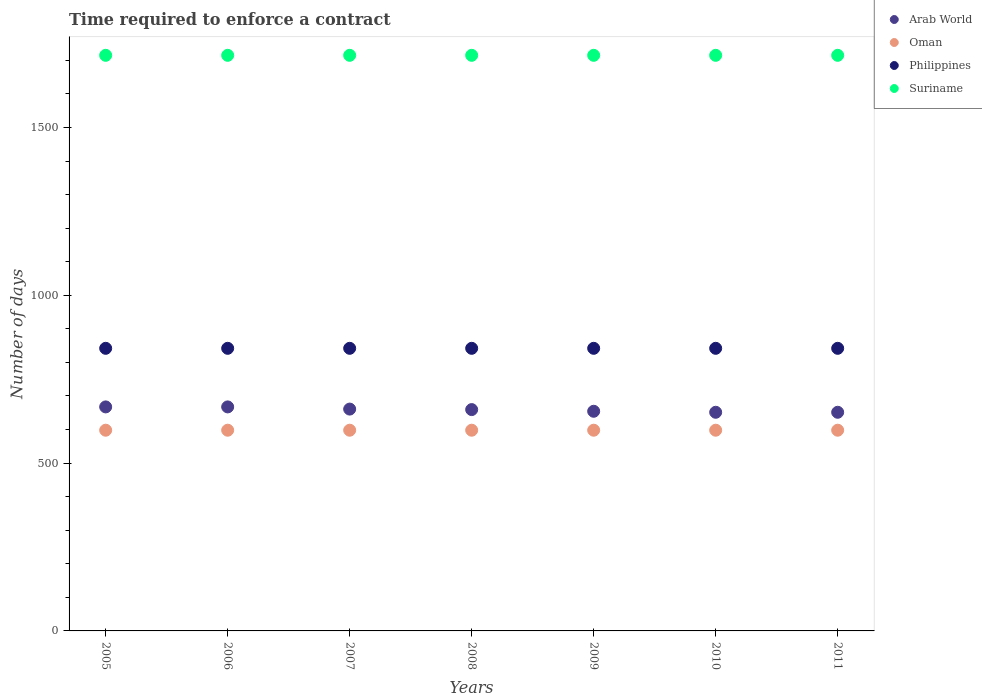What is the number of days required to enforce a contract in Oman in 2007?
Ensure brevity in your answer.  598. Across all years, what is the maximum number of days required to enforce a contract in Oman?
Your answer should be very brief. 598. Across all years, what is the minimum number of days required to enforce a contract in Arab World?
Give a very brief answer. 651.45. In which year was the number of days required to enforce a contract in Suriname maximum?
Ensure brevity in your answer.  2005. What is the total number of days required to enforce a contract in Suriname in the graph?
Offer a terse response. 1.20e+04. What is the difference between the number of days required to enforce a contract in Arab World in 2006 and that in 2008?
Give a very brief answer. 7.99. What is the difference between the number of days required to enforce a contract in Suriname in 2006 and the number of days required to enforce a contract in Philippines in 2010?
Your response must be concise. 873. What is the average number of days required to enforce a contract in Oman per year?
Your answer should be compact. 598. In the year 2006, what is the difference between the number of days required to enforce a contract in Arab World and number of days required to enforce a contract in Oman?
Give a very brief answer. 69.44. In how many years, is the number of days required to enforce a contract in Philippines greater than 1200 days?
Your response must be concise. 0. What is the ratio of the number of days required to enforce a contract in Suriname in 2008 to that in 2009?
Ensure brevity in your answer.  1. Is the difference between the number of days required to enforce a contract in Arab World in 2005 and 2008 greater than the difference between the number of days required to enforce a contract in Oman in 2005 and 2008?
Provide a short and direct response. Yes. What is the difference between the highest and the lowest number of days required to enforce a contract in Suriname?
Provide a short and direct response. 0. In how many years, is the number of days required to enforce a contract in Philippines greater than the average number of days required to enforce a contract in Philippines taken over all years?
Offer a very short reply. 0. Is it the case that in every year, the sum of the number of days required to enforce a contract in Arab World and number of days required to enforce a contract in Oman  is greater than the number of days required to enforce a contract in Suriname?
Give a very brief answer. No. Is the number of days required to enforce a contract in Oman strictly greater than the number of days required to enforce a contract in Suriname over the years?
Give a very brief answer. No. How many years are there in the graph?
Make the answer very short. 7. What is the difference between two consecutive major ticks on the Y-axis?
Offer a terse response. 500. Where does the legend appear in the graph?
Ensure brevity in your answer.  Top right. How are the legend labels stacked?
Your answer should be compact. Vertical. What is the title of the graph?
Provide a short and direct response. Time required to enforce a contract. Does "St. Martin (French part)" appear as one of the legend labels in the graph?
Provide a succinct answer. No. What is the label or title of the Y-axis?
Your answer should be very brief. Number of days. What is the Number of days of Arab World in 2005?
Your answer should be very brief. 667.44. What is the Number of days in Oman in 2005?
Provide a short and direct response. 598. What is the Number of days of Philippines in 2005?
Give a very brief answer. 842. What is the Number of days in Suriname in 2005?
Keep it short and to the point. 1715. What is the Number of days in Arab World in 2006?
Provide a succinct answer. 667.44. What is the Number of days in Oman in 2006?
Keep it short and to the point. 598. What is the Number of days in Philippines in 2006?
Ensure brevity in your answer.  842. What is the Number of days in Suriname in 2006?
Provide a succinct answer. 1715. What is the Number of days in Arab World in 2007?
Give a very brief answer. 660.95. What is the Number of days in Oman in 2007?
Your response must be concise. 598. What is the Number of days of Philippines in 2007?
Make the answer very short. 842. What is the Number of days in Suriname in 2007?
Offer a terse response. 1715. What is the Number of days of Arab World in 2008?
Give a very brief answer. 659.45. What is the Number of days of Oman in 2008?
Your answer should be very brief. 598. What is the Number of days of Philippines in 2008?
Ensure brevity in your answer.  842. What is the Number of days of Suriname in 2008?
Keep it short and to the point. 1715. What is the Number of days of Arab World in 2009?
Give a very brief answer. 654.45. What is the Number of days of Oman in 2009?
Your answer should be compact. 598. What is the Number of days of Philippines in 2009?
Your response must be concise. 842. What is the Number of days of Suriname in 2009?
Provide a succinct answer. 1715. What is the Number of days in Arab World in 2010?
Your answer should be very brief. 651.45. What is the Number of days in Oman in 2010?
Provide a short and direct response. 598. What is the Number of days of Philippines in 2010?
Your answer should be compact. 842. What is the Number of days of Suriname in 2010?
Offer a very short reply. 1715. What is the Number of days of Arab World in 2011?
Provide a succinct answer. 651.45. What is the Number of days in Oman in 2011?
Provide a succinct answer. 598. What is the Number of days in Philippines in 2011?
Provide a short and direct response. 842. What is the Number of days in Suriname in 2011?
Ensure brevity in your answer.  1715. Across all years, what is the maximum Number of days of Arab World?
Keep it short and to the point. 667.44. Across all years, what is the maximum Number of days of Oman?
Your response must be concise. 598. Across all years, what is the maximum Number of days in Philippines?
Ensure brevity in your answer.  842. Across all years, what is the maximum Number of days of Suriname?
Offer a very short reply. 1715. Across all years, what is the minimum Number of days in Arab World?
Keep it short and to the point. 651.45. Across all years, what is the minimum Number of days in Oman?
Offer a terse response. 598. Across all years, what is the minimum Number of days in Philippines?
Offer a terse response. 842. Across all years, what is the minimum Number of days in Suriname?
Provide a short and direct response. 1715. What is the total Number of days of Arab World in the graph?
Your answer should be compact. 4612.64. What is the total Number of days in Oman in the graph?
Ensure brevity in your answer.  4186. What is the total Number of days of Philippines in the graph?
Offer a terse response. 5894. What is the total Number of days in Suriname in the graph?
Ensure brevity in your answer.  1.20e+04. What is the difference between the Number of days in Arab World in 2005 and that in 2006?
Provide a succinct answer. 0. What is the difference between the Number of days in Arab World in 2005 and that in 2007?
Provide a short and direct response. 6.49. What is the difference between the Number of days of Philippines in 2005 and that in 2007?
Your answer should be compact. 0. What is the difference between the Number of days of Suriname in 2005 and that in 2007?
Keep it short and to the point. 0. What is the difference between the Number of days of Arab World in 2005 and that in 2008?
Ensure brevity in your answer.  7.99. What is the difference between the Number of days in Oman in 2005 and that in 2008?
Your response must be concise. 0. What is the difference between the Number of days in Philippines in 2005 and that in 2008?
Keep it short and to the point. 0. What is the difference between the Number of days of Arab World in 2005 and that in 2009?
Provide a succinct answer. 12.99. What is the difference between the Number of days of Philippines in 2005 and that in 2009?
Your response must be concise. 0. What is the difference between the Number of days in Suriname in 2005 and that in 2009?
Provide a succinct answer. 0. What is the difference between the Number of days in Arab World in 2005 and that in 2010?
Provide a succinct answer. 15.99. What is the difference between the Number of days in Oman in 2005 and that in 2010?
Make the answer very short. 0. What is the difference between the Number of days of Suriname in 2005 and that in 2010?
Keep it short and to the point. 0. What is the difference between the Number of days in Arab World in 2005 and that in 2011?
Ensure brevity in your answer.  15.99. What is the difference between the Number of days in Arab World in 2006 and that in 2007?
Your response must be concise. 6.49. What is the difference between the Number of days of Oman in 2006 and that in 2007?
Your response must be concise. 0. What is the difference between the Number of days of Philippines in 2006 and that in 2007?
Keep it short and to the point. 0. What is the difference between the Number of days of Suriname in 2006 and that in 2007?
Provide a short and direct response. 0. What is the difference between the Number of days of Arab World in 2006 and that in 2008?
Your answer should be compact. 7.99. What is the difference between the Number of days of Oman in 2006 and that in 2008?
Keep it short and to the point. 0. What is the difference between the Number of days in Arab World in 2006 and that in 2009?
Provide a succinct answer. 12.99. What is the difference between the Number of days in Oman in 2006 and that in 2009?
Offer a very short reply. 0. What is the difference between the Number of days of Philippines in 2006 and that in 2009?
Keep it short and to the point. 0. What is the difference between the Number of days of Arab World in 2006 and that in 2010?
Offer a very short reply. 15.99. What is the difference between the Number of days in Suriname in 2006 and that in 2010?
Provide a short and direct response. 0. What is the difference between the Number of days of Arab World in 2006 and that in 2011?
Keep it short and to the point. 15.99. What is the difference between the Number of days in Oman in 2007 and that in 2008?
Offer a very short reply. 0. What is the difference between the Number of days in Suriname in 2007 and that in 2008?
Keep it short and to the point. 0. What is the difference between the Number of days of Arab World in 2007 and that in 2009?
Your answer should be compact. 6.5. What is the difference between the Number of days of Oman in 2007 and that in 2009?
Provide a short and direct response. 0. What is the difference between the Number of days of Philippines in 2007 and that in 2009?
Your response must be concise. 0. What is the difference between the Number of days of Philippines in 2007 and that in 2010?
Offer a very short reply. 0. What is the difference between the Number of days in Arab World in 2007 and that in 2011?
Ensure brevity in your answer.  9.5. What is the difference between the Number of days of Suriname in 2007 and that in 2011?
Provide a succinct answer. 0. What is the difference between the Number of days of Arab World in 2008 and that in 2009?
Give a very brief answer. 5. What is the difference between the Number of days of Arab World in 2008 and that in 2010?
Your answer should be very brief. 8. What is the difference between the Number of days in Philippines in 2008 and that in 2010?
Ensure brevity in your answer.  0. What is the difference between the Number of days of Suriname in 2008 and that in 2010?
Your answer should be compact. 0. What is the difference between the Number of days in Suriname in 2008 and that in 2011?
Provide a succinct answer. 0. What is the difference between the Number of days of Arab World in 2009 and that in 2010?
Your response must be concise. 3. What is the difference between the Number of days in Suriname in 2009 and that in 2010?
Keep it short and to the point. 0. What is the difference between the Number of days of Oman in 2009 and that in 2011?
Make the answer very short. 0. What is the difference between the Number of days of Philippines in 2009 and that in 2011?
Offer a terse response. 0. What is the difference between the Number of days of Arab World in 2005 and the Number of days of Oman in 2006?
Offer a very short reply. 69.44. What is the difference between the Number of days in Arab World in 2005 and the Number of days in Philippines in 2006?
Your answer should be compact. -174.56. What is the difference between the Number of days of Arab World in 2005 and the Number of days of Suriname in 2006?
Give a very brief answer. -1047.56. What is the difference between the Number of days in Oman in 2005 and the Number of days in Philippines in 2006?
Offer a terse response. -244. What is the difference between the Number of days in Oman in 2005 and the Number of days in Suriname in 2006?
Keep it short and to the point. -1117. What is the difference between the Number of days in Philippines in 2005 and the Number of days in Suriname in 2006?
Provide a short and direct response. -873. What is the difference between the Number of days of Arab World in 2005 and the Number of days of Oman in 2007?
Your answer should be very brief. 69.44. What is the difference between the Number of days in Arab World in 2005 and the Number of days in Philippines in 2007?
Make the answer very short. -174.56. What is the difference between the Number of days in Arab World in 2005 and the Number of days in Suriname in 2007?
Give a very brief answer. -1047.56. What is the difference between the Number of days of Oman in 2005 and the Number of days of Philippines in 2007?
Your answer should be compact. -244. What is the difference between the Number of days of Oman in 2005 and the Number of days of Suriname in 2007?
Keep it short and to the point. -1117. What is the difference between the Number of days in Philippines in 2005 and the Number of days in Suriname in 2007?
Your response must be concise. -873. What is the difference between the Number of days of Arab World in 2005 and the Number of days of Oman in 2008?
Your answer should be compact. 69.44. What is the difference between the Number of days of Arab World in 2005 and the Number of days of Philippines in 2008?
Ensure brevity in your answer.  -174.56. What is the difference between the Number of days in Arab World in 2005 and the Number of days in Suriname in 2008?
Provide a short and direct response. -1047.56. What is the difference between the Number of days of Oman in 2005 and the Number of days of Philippines in 2008?
Offer a terse response. -244. What is the difference between the Number of days of Oman in 2005 and the Number of days of Suriname in 2008?
Ensure brevity in your answer.  -1117. What is the difference between the Number of days of Philippines in 2005 and the Number of days of Suriname in 2008?
Your answer should be compact. -873. What is the difference between the Number of days in Arab World in 2005 and the Number of days in Oman in 2009?
Offer a very short reply. 69.44. What is the difference between the Number of days of Arab World in 2005 and the Number of days of Philippines in 2009?
Provide a short and direct response. -174.56. What is the difference between the Number of days of Arab World in 2005 and the Number of days of Suriname in 2009?
Your response must be concise. -1047.56. What is the difference between the Number of days in Oman in 2005 and the Number of days in Philippines in 2009?
Provide a succinct answer. -244. What is the difference between the Number of days of Oman in 2005 and the Number of days of Suriname in 2009?
Give a very brief answer. -1117. What is the difference between the Number of days of Philippines in 2005 and the Number of days of Suriname in 2009?
Give a very brief answer. -873. What is the difference between the Number of days of Arab World in 2005 and the Number of days of Oman in 2010?
Keep it short and to the point. 69.44. What is the difference between the Number of days in Arab World in 2005 and the Number of days in Philippines in 2010?
Your answer should be compact. -174.56. What is the difference between the Number of days of Arab World in 2005 and the Number of days of Suriname in 2010?
Give a very brief answer. -1047.56. What is the difference between the Number of days in Oman in 2005 and the Number of days in Philippines in 2010?
Your response must be concise. -244. What is the difference between the Number of days in Oman in 2005 and the Number of days in Suriname in 2010?
Offer a terse response. -1117. What is the difference between the Number of days of Philippines in 2005 and the Number of days of Suriname in 2010?
Offer a very short reply. -873. What is the difference between the Number of days in Arab World in 2005 and the Number of days in Oman in 2011?
Keep it short and to the point. 69.44. What is the difference between the Number of days of Arab World in 2005 and the Number of days of Philippines in 2011?
Make the answer very short. -174.56. What is the difference between the Number of days in Arab World in 2005 and the Number of days in Suriname in 2011?
Provide a succinct answer. -1047.56. What is the difference between the Number of days in Oman in 2005 and the Number of days in Philippines in 2011?
Offer a terse response. -244. What is the difference between the Number of days in Oman in 2005 and the Number of days in Suriname in 2011?
Offer a very short reply. -1117. What is the difference between the Number of days in Philippines in 2005 and the Number of days in Suriname in 2011?
Provide a short and direct response. -873. What is the difference between the Number of days in Arab World in 2006 and the Number of days in Oman in 2007?
Ensure brevity in your answer.  69.44. What is the difference between the Number of days in Arab World in 2006 and the Number of days in Philippines in 2007?
Offer a very short reply. -174.56. What is the difference between the Number of days in Arab World in 2006 and the Number of days in Suriname in 2007?
Ensure brevity in your answer.  -1047.56. What is the difference between the Number of days in Oman in 2006 and the Number of days in Philippines in 2007?
Your answer should be compact. -244. What is the difference between the Number of days in Oman in 2006 and the Number of days in Suriname in 2007?
Offer a very short reply. -1117. What is the difference between the Number of days of Philippines in 2006 and the Number of days of Suriname in 2007?
Your answer should be very brief. -873. What is the difference between the Number of days of Arab World in 2006 and the Number of days of Oman in 2008?
Your response must be concise. 69.44. What is the difference between the Number of days of Arab World in 2006 and the Number of days of Philippines in 2008?
Give a very brief answer. -174.56. What is the difference between the Number of days of Arab World in 2006 and the Number of days of Suriname in 2008?
Make the answer very short. -1047.56. What is the difference between the Number of days of Oman in 2006 and the Number of days of Philippines in 2008?
Your answer should be compact. -244. What is the difference between the Number of days of Oman in 2006 and the Number of days of Suriname in 2008?
Give a very brief answer. -1117. What is the difference between the Number of days in Philippines in 2006 and the Number of days in Suriname in 2008?
Your answer should be compact. -873. What is the difference between the Number of days in Arab World in 2006 and the Number of days in Oman in 2009?
Offer a terse response. 69.44. What is the difference between the Number of days of Arab World in 2006 and the Number of days of Philippines in 2009?
Keep it short and to the point. -174.56. What is the difference between the Number of days of Arab World in 2006 and the Number of days of Suriname in 2009?
Make the answer very short. -1047.56. What is the difference between the Number of days of Oman in 2006 and the Number of days of Philippines in 2009?
Make the answer very short. -244. What is the difference between the Number of days of Oman in 2006 and the Number of days of Suriname in 2009?
Your answer should be compact. -1117. What is the difference between the Number of days in Philippines in 2006 and the Number of days in Suriname in 2009?
Keep it short and to the point. -873. What is the difference between the Number of days of Arab World in 2006 and the Number of days of Oman in 2010?
Offer a very short reply. 69.44. What is the difference between the Number of days of Arab World in 2006 and the Number of days of Philippines in 2010?
Ensure brevity in your answer.  -174.56. What is the difference between the Number of days of Arab World in 2006 and the Number of days of Suriname in 2010?
Keep it short and to the point. -1047.56. What is the difference between the Number of days in Oman in 2006 and the Number of days in Philippines in 2010?
Give a very brief answer. -244. What is the difference between the Number of days in Oman in 2006 and the Number of days in Suriname in 2010?
Give a very brief answer. -1117. What is the difference between the Number of days of Philippines in 2006 and the Number of days of Suriname in 2010?
Your answer should be compact. -873. What is the difference between the Number of days in Arab World in 2006 and the Number of days in Oman in 2011?
Your response must be concise. 69.44. What is the difference between the Number of days of Arab World in 2006 and the Number of days of Philippines in 2011?
Provide a short and direct response. -174.56. What is the difference between the Number of days in Arab World in 2006 and the Number of days in Suriname in 2011?
Make the answer very short. -1047.56. What is the difference between the Number of days in Oman in 2006 and the Number of days in Philippines in 2011?
Give a very brief answer. -244. What is the difference between the Number of days in Oman in 2006 and the Number of days in Suriname in 2011?
Your response must be concise. -1117. What is the difference between the Number of days of Philippines in 2006 and the Number of days of Suriname in 2011?
Offer a terse response. -873. What is the difference between the Number of days of Arab World in 2007 and the Number of days of Oman in 2008?
Your answer should be very brief. 62.95. What is the difference between the Number of days in Arab World in 2007 and the Number of days in Philippines in 2008?
Give a very brief answer. -181.05. What is the difference between the Number of days in Arab World in 2007 and the Number of days in Suriname in 2008?
Make the answer very short. -1054.05. What is the difference between the Number of days of Oman in 2007 and the Number of days of Philippines in 2008?
Make the answer very short. -244. What is the difference between the Number of days in Oman in 2007 and the Number of days in Suriname in 2008?
Make the answer very short. -1117. What is the difference between the Number of days in Philippines in 2007 and the Number of days in Suriname in 2008?
Your response must be concise. -873. What is the difference between the Number of days in Arab World in 2007 and the Number of days in Oman in 2009?
Your answer should be very brief. 62.95. What is the difference between the Number of days of Arab World in 2007 and the Number of days of Philippines in 2009?
Provide a short and direct response. -181.05. What is the difference between the Number of days of Arab World in 2007 and the Number of days of Suriname in 2009?
Your answer should be very brief. -1054.05. What is the difference between the Number of days of Oman in 2007 and the Number of days of Philippines in 2009?
Give a very brief answer. -244. What is the difference between the Number of days in Oman in 2007 and the Number of days in Suriname in 2009?
Keep it short and to the point. -1117. What is the difference between the Number of days in Philippines in 2007 and the Number of days in Suriname in 2009?
Your response must be concise. -873. What is the difference between the Number of days in Arab World in 2007 and the Number of days in Oman in 2010?
Provide a short and direct response. 62.95. What is the difference between the Number of days in Arab World in 2007 and the Number of days in Philippines in 2010?
Keep it short and to the point. -181.05. What is the difference between the Number of days of Arab World in 2007 and the Number of days of Suriname in 2010?
Keep it short and to the point. -1054.05. What is the difference between the Number of days of Oman in 2007 and the Number of days of Philippines in 2010?
Offer a very short reply. -244. What is the difference between the Number of days of Oman in 2007 and the Number of days of Suriname in 2010?
Offer a terse response. -1117. What is the difference between the Number of days of Philippines in 2007 and the Number of days of Suriname in 2010?
Keep it short and to the point. -873. What is the difference between the Number of days in Arab World in 2007 and the Number of days in Oman in 2011?
Your response must be concise. 62.95. What is the difference between the Number of days in Arab World in 2007 and the Number of days in Philippines in 2011?
Give a very brief answer. -181.05. What is the difference between the Number of days of Arab World in 2007 and the Number of days of Suriname in 2011?
Offer a very short reply. -1054.05. What is the difference between the Number of days in Oman in 2007 and the Number of days in Philippines in 2011?
Provide a succinct answer. -244. What is the difference between the Number of days of Oman in 2007 and the Number of days of Suriname in 2011?
Keep it short and to the point. -1117. What is the difference between the Number of days of Philippines in 2007 and the Number of days of Suriname in 2011?
Ensure brevity in your answer.  -873. What is the difference between the Number of days in Arab World in 2008 and the Number of days in Oman in 2009?
Provide a succinct answer. 61.45. What is the difference between the Number of days of Arab World in 2008 and the Number of days of Philippines in 2009?
Provide a succinct answer. -182.55. What is the difference between the Number of days of Arab World in 2008 and the Number of days of Suriname in 2009?
Give a very brief answer. -1055.55. What is the difference between the Number of days of Oman in 2008 and the Number of days of Philippines in 2009?
Your response must be concise. -244. What is the difference between the Number of days in Oman in 2008 and the Number of days in Suriname in 2009?
Make the answer very short. -1117. What is the difference between the Number of days of Philippines in 2008 and the Number of days of Suriname in 2009?
Your answer should be compact. -873. What is the difference between the Number of days of Arab World in 2008 and the Number of days of Oman in 2010?
Make the answer very short. 61.45. What is the difference between the Number of days of Arab World in 2008 and the Number of days of Philippines in 2010?
Offer a terse response. -182.55. What is the difference between the Number of days of Arab World in 2008 and the Number of days of Suriname in 2010?
Your answer should be compact. -1055.55. What is the difference between the Number of days of Oman in 2008 and the Number of days of Philippines in 2010?
Your answer should be compact. -244. What is the difference between the Number of days in Oman in 2008 and the Number of days in Suriname in 2010?
Make the answer very short. -1117. What is the difference between the Number of days in Philippines in 2008 and the Number of days in Suriname in 2010?
Your answer should be very brief. -873. What is the difference between the Number of days in Arab World in 2008 and the Number of days in Oman in 2011?
Offer a terse response. 61.45. What is the difference between the Number of days of Arab World in 2008 and the Number of days of Philippines in 2011?
Provide a short and direct response. -182.55. What is the difference between the Number of days in Arab World in 2008 and the Number of days in Suriname in 2011?
Your response must be concise. -1055.55. What is the difference between the Number of days of Oman in 2008 and the Number of days of Philippines in 2011?
Provide a succinct answer. -244. What is the difference between the Number of days in Oman in 2008 and the Number of days in Suriname in 2011?
Provide a succinct answer. -1117. What is the difference between the Number of days of Philippines in 2008 and the Number of days of Suriname in 2011?
Keep it short and to the point. -873. What is the difference between the Number of days of Arab World in 2009 and the Number of days of Oman in 2010?
Your answer should be compact. 56.45. What is the difference between the Number of days in Arab World in 2009 and the Number of days in Philippines in 2010?
Your answer should be compact. -187.55. What is the difference between the Number of days of Arab World in 2009 and the Number of days of Suriname in 2010?
Offer a very short reply. -1060.55. What is the difference between the Number of days of Oman in 2009 and the Number of days of Philippines in 2010?
Offer a terse response. -244. What is the difference between the Number of days of Oman in 2009 and the Number of days of Suriname in 2010?
Ensure brevity in your answer.  -1117. What is the difference between the Number of days in Philippines in 2009 and the Number of days in Suriname in 2010?
Your answer should be very brief. -873. What is the difference between the Number of days in Arab World in 2009 and the Number of days in Oman in 2011?
Your answer should be compact. 56.45. What is the difference between the Number of days of Arab World in 2009 and the Number of days of Philippines in 2011?
Give a very brief answer. -187.55. What is the difference between the Number of days of Arab World in 2009 and the Number of days of Suriname in 2011?
Make the answer very short. -1060.55. What is the difference between the Number of days in Oman in 2009 and the Number of days in Philippines in 2011?
Keep it short and to the point. -244. What is the difference between the Number of days of Oman in 2009 and the Number of days of Suriname in 2011?
Keep it short and to the point. -1117. What is the difference between the Number of days of Philippines in 2009 and the Number of days of Suriname in 2011?
Give a very brief answer. -873. What is the difference between the Number of days in Arab World in 2010 and the Number of days in Oman in 2011?
Offer a very short reply. 53.45. What is the difference between the Number of days in Arab World in 2010 and the Number of days in Philippines in 2011?
Make the answer very short. -190.55. What is the difference between the Number of days of Arab World in 2010 and the Number of days of Suriname in 2011?
Keep it short and to the point. -1063.55. What is the difference between the Number of days in Oman in 2010 and the Number of days in Philippines in 2011?
Keep it short and to the point. -244. What is the difference between the Number of days of Oman in 2010 and the Number of days of Suriname in 2011?
Make the answer very short. -1117. What is the difference between the Number of days in Philippines in 2010 and the Number of days in Suriname in 2011?
Give a very brief answer. -873. What is the average Number of days of Arab World per year?
Provide a short and direct response. 658.95. What is the average Number of days in Oman per year?
Make the answer very short. 598. What is the average Number of days of Philippines per year?
Your answer should be compact. 842. What is the average Number of days in Suriname per year?
Your answer should be compact. 1715. In the year 2005, what is the difference between the Number of days in Arab World and Number of days in Oman?
Ensure brevity in your answer.  69.44. In the year 2005, what is the difference between the Number of days of Arab World and Number of days of Philippines?
Your answer should be compact. -174.56. In the year 2005, what is the difference between the Number of days in Arab World and Number of days in Suriname?
Keep it short and to the point. -1047.56. In the year 2005, what is the difference between the Number of days in Oman and Number of days in Philippines?
Your answer should be compact. -244. In the year 2005, what is the difference between the Number of days of Oman and Number of days of Suriname?
Keep it short and to the point. -1117. In the year 2005, what is the difference between the Number of days in Philippines and Number of days in Suriname?
Keep it short and to the point. -873. In the year 2006, what is the difference between the Number of days in Arab World and Number of days in Oman?
Your answer should be very brief. 69.44. In the year 2006, what is the difference between the Number of days of Arab World and Number of days of Philippines?
Provide a succinct answer. -174.56. In the year 2006, what is the difference between the Number of days of Arab World and Number of days of Suriname?
Your answer should be compact. -1047.56. In the year 2006, what is the difference between the Number of days of Oman and Number of days of Philippines?
Provide a short and direct response. -244. In the year 2006, what is the difference between the Number of days in Oman and Number of days in Suriname?
Ensure brevity in your answer.  -1117. In the year 2006, what is the difference between the Number of days of Philippines and Number of days of Suriname?
Offer a very short reply. -873. In the year 2007, what is the difference between the Number of days in Arab World and Number of days in Oman?
Provide a short and direct response. 62.95. In the year 2007, what is the difference between the Number of days of Arab World and Number of days of Philippines?
Your response must be concise. -181.05. In the year 2007, what is the difference between the Number of days in Arab World and Number of days in Suriname?
Give a very brief answer. -1054.05. In the year 2007, what is the difference between the Number of days in Oman and Number of days in Philippines?
Provide a succinct answer. -244. In the year 2007, what is the difference between the Number of days of Oman and Number of days of Suriname?
Your response must be concise. -1117. In the year 2007, what is the difference between the Number of days in Philippines and Number of days in Suriname?
Keep it short and to the point. -873. In the year 2008, what is the difference between the Number of days of Arab World and Number of days of Oman?
Give a very brief answer. 61.45. In the year 2008, what is the difference between the Number of days in Arab World and Number of days in Philippines?
Ensure brevity in your answer.  -182.55. In the year 2008, what is the difference between the Number of days of Arab World and Number of days of Suriname?
Make the answer very short. -1055.55. In the year 2008, what is the difference between the Number of days in Oman and Number of days in Philippines?
Your answer should be very brief. -244. In the year 2008, what is the difference between the Number of days in Oman and Number of days in Suriname?
Provide a short and direct response. -1117. In the year 2008, what is the difference between the Number of days in Philippines and Number of days in Suriname?
Provide a short and direct response. -873. In the year 2009, what is the difference between the Number of days in Arab World and Number of days in Oman?
Offer a very short reply. 56.45. In the year 2009, what is the difference between the Number of days of Arab World and Number of days of Philippines?
Your answer should be compact. -187.55. In the year 2009, what is the difference between the Number of days in Arab World and Number of days in Suriname?
Ensure brevity in your answer.  -1060.55. In the year 2009, what is the difference between the Number of days of Oman and Number of days of Philippines?
Your answer should be compact. -244. In the year 2009, what is the difference between the Number of days in Oman and Number of days in Suriname?
Your answer should be very brief. -1117. In the year 2009, what is the difference between the Number of days in Philippines and Number of days in Suriname?
Ensure brevity in your answer.  -873. In the year 2010, what is the difference between the Number of days of Arab World and Number of days of Oman?
Make the answer very short. 53.45. In the year 2010, what is the difference between the Number of days of Arab World and Number of days of Philippines?
Offer a terse response. -190.55. In the year 2010, what is the difference between the Number of days of Arab World and Number of days of Suriname?
Your answer should be compact. -1063.55. In the year 2010, what is the difference between the Number of days of Oman and Number of days of Philippines?
Your answer should be compact. -244. In the year 2010, what is the difference between the Number of days of Oman and Number of days of Suriname?
Provide a succinct answer. -1117. In the year 2010, what is the difference between the Number of days in Philippines and Number of days in Suriname?
Offer a terse response. -873. In the year 2011, what is the difference between the Number of days of Arab World and Number of days of Oman?
Provide a short and direct response. 53.45. In the year 2011, what is the difference between the Number of days in Arab World and Number of days in Philippines?
Ensure brevity in your answer.  -190.55. In the year 2011, what is the difference between the Number of days of Arab World and Number of days of Suriname?
Your answer should be very brief. -1063.55. In the year 2011, what is the difference between the Number of days of Oman and Number of days of Philippines?
Your answer should be compact. -244. In the year 2011, what is the difference between the Number of days of Oman and Number of days of Suriname?
Keep it short and to the point. -1117. In the year 2011, what is the difference between the Number of days in Philippines and Number of days in Suriname?
Your answer should be compact. -873. What is the ratio of the Number of days of Arab World in 2005 to that in 2007?
Offer a terse response. 1.01. What is the ratio of the Number of days in Philippines in 2005 to that in 2007?
Provide a short and direct response. 1. What is the ratio of the Number of days in Suriname in 2005 to that in 2007?
Give a very brief answer. 1. What is the ratio of the Number of days of Arab World in 2005 to that in 2008?
Provide a succinct answer. 1.01. What is the ratio of the Number of days in Arab World in 2005 to that in 2009?
Your response must be concise. 1.02. What is the ratio of the Number of days of Oman in 2005 to that in 2009?
Your response must be concise. 1. What is the ratio of the Number of days in Suriname in 2005 to that in 2009?
Your answer should be compact. 1. What is the ratio of the Number of days of Arab World in 2005 to that in 2010?
Your answer should be compact. 1.02. What is the ratio of the Number of days in Oman in 2005 to that in 2010?
Ensure brevity in your answer.  1. What is the ratio of the Number of days in Arab World in 2005 to that in 2011?
Provide a short and direct response. 1.02. What is the ratio of the Number of days of Oman in 2005 to that in 2011?
Ensure brevity in your answer.  1. What is the ratio of the Number of days of Suriname in 2005 to that in 2011?
Offer a terse response. 1. What is the ratio of the Number of days of Arab World in 2006 to that in 2007?
Your answer should be very brief. 1.01. What is the ratio of the Number of days of Oman in 2006 to that in 2007?
Provide a succinct answer. 1. What is the ratio of the Number of days of Arab World in 2006 to that in 2008?
Offer a very short reply. 1.01. What is the ratio of the Number of days of Oman in 2006 to that in 2008?
Offer a very short reply. 1. What is the ratio of the Number of days in Philippines in 2006 to that in 2008?
Ensure brevity in your answer.  1. What is the ratio of the Number of days of Arab World in 2006 to that in 2009?
Give a very brief answer. 1.02. What is the ratio of the Number of days in Oman in 2006 to that in 2009?
Give a very brief answer. 1. What is the ratio of the Number of days in Philippines in 2006 to that in 2009?
Provide a succinct answer. 1. What is the ratio of the Number of days in Arab World in 2006 to that in 2010?
Give a very brief answer. 1.02. What is the ratio of the Number of days of Suriname in 2006 to that in 2010?
Offer a very short reply. 1. What is the ratio of the Number of days of Arab World in 2006 to that in 2011?
Your answer should be very brief. 1.02. What is the ratio of the Number of days of Oman in 2007 to that in 2008?
Give a very brief answer. 1. What is the ratio of the Number of days in Suriname in 2007 to that in 2008?
Your answer should be very brief. 1. What is the ratio of the Number of days of Arab World in 2007 to that in 2009?
Offer a very short reply. 1.01. What is the ratio of the Number of days in Arab World in 2007 to that in 2010?
Offer a terse response. 1.01. What is the ratio of the Number of days of Arab World in 2007 to that in 2011?
Give a very brief answer. 1.01. What is the ratio of the Number of days in Oman in 2007 to that in 2011?
Keep it short and to the point. 1. What is the ratio of the Number of days in Arab World in 2008 to that in 2009?
Make the answer very short. 1.01. What is the ratio of the Number of days in Oman in 2008 to that in 2009?
Keep it short and to the point. 1. What is the ratio of the Number of days in Arab World in 2008 to that in 2010?
Give a very brief answer. 1.01. What is the ratio of the Number of days of Philippines in 2008 to that in 2010?
Make the answer very short. 1. What is the ratio of the Number of days of Suriname in 2008 to that in 2010?
Provide a succinct answer. 1. What is the ratio of the Number of days of Arab World in 2008 to that in 2011?
Keep it short and to the point. 1.01. What is the ratio of the Number of days of Philippines in 2008 to that in 2011?
Your answer should be very brief. 1. What is the ratio of the Number of days in Oman in 2009 to that in 2010?
Offer a very short reply. 1. What is the ratio of the Number of days in Philippines in 2009 to that in 2010?
Your answer should be very brief. 1. What is the ratio of the Number of days of Suriname in 2009 to that in 2010?
Give a very brief answer. 1. What is the ratio of the Number of days in Philippines in 2009 to that in 2011?
Your answer should be compact. 1. What is the ratio of the Number of days in Oman in 2010 to that in 2011?
Keep it short and to the point. 1. What is the ratio of the Number of days in Philippines in 2010 to that in 2011?
Make the answer very short. 1. What is the difference between the highest and the second highest Number of days of Arab World?
Your answer should be compact. 0. What is the difference between the highest and the second highest Number of days of Oman?
Your response must be concise. 0. What is the difference between the highest and the lowest Number of days of Arab World?
Give a very brief answer. 15.99. What is the difference between the highest and the lowest Number of days in Oman?
Ensure brevity in your answer.  0. 